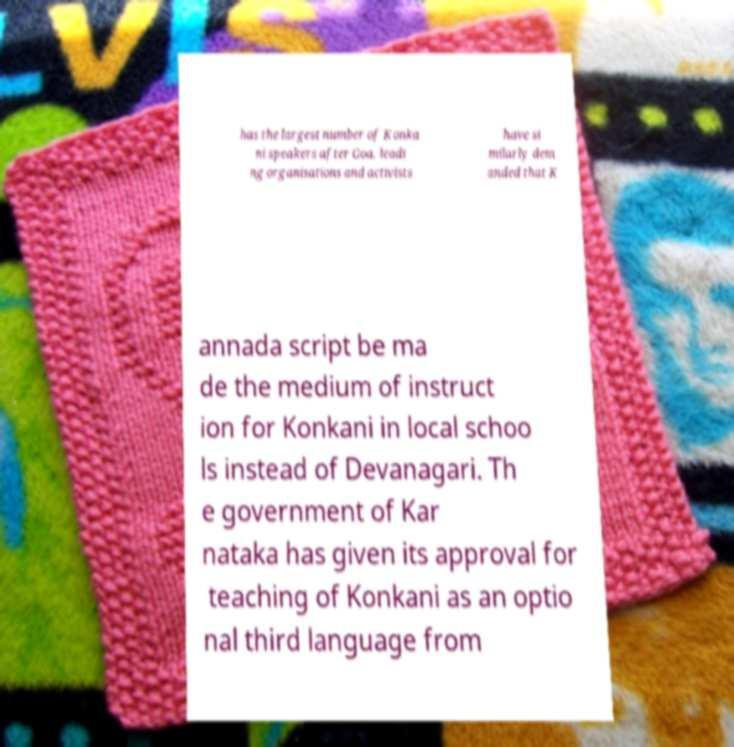Could you assist in decoding the text presented in this image and type it out clearly? has the largest number of Konka ni speakers after Goa, leadi ng organisations and activists have si milarly dem anded that K annada script be ma de the medium of instruct ion for Konkani in local schoo ls instead of Devanagari. Th e government of Kar nataka has given its approval for teaching of Konkani as an optio nal third language from 